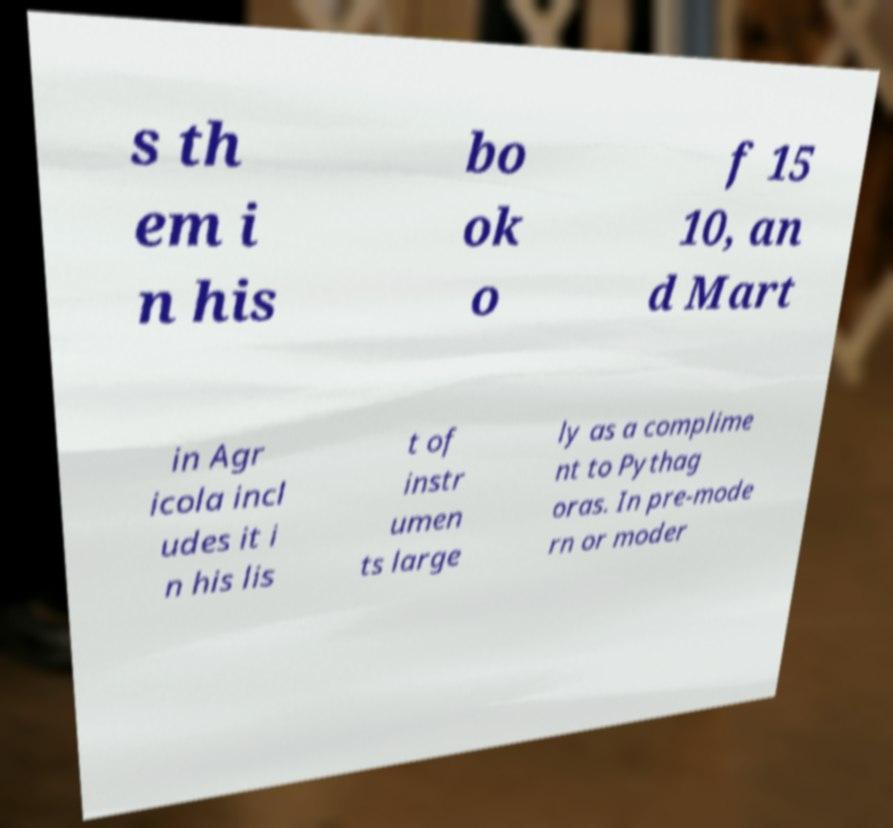What messages or text are displayed in this image? I need them in a readable, typed format. s th em i n his bo ok o f 15 10, an d Mart in Agr icola incl udes it i n his lis t of instr umen ts large ly as a complime nt to Pythag oras. In pre-mode rn or moder 